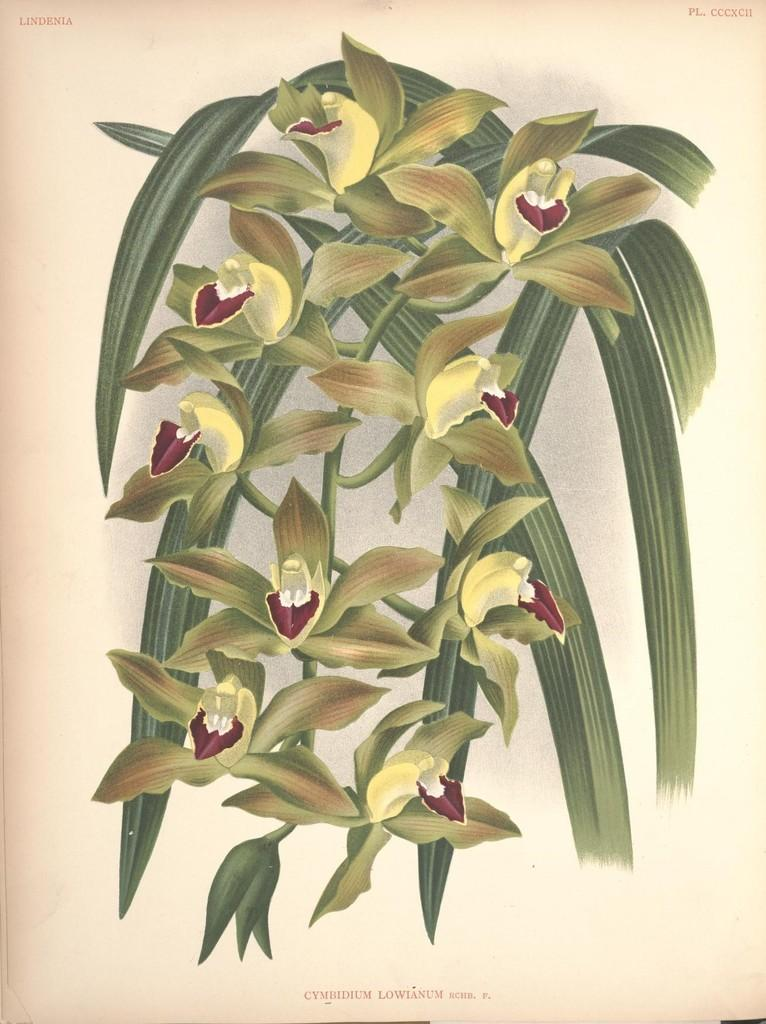What is the main subject of the image? There is a painting in the image. What is depicted in the painting? The painting contains flowers. What type of game is being played in the painting? There is no game being played in the painting; it contains flowers. How many masses can be seen in the painting? There are no masses depicted in the painting; it contains flowers. 